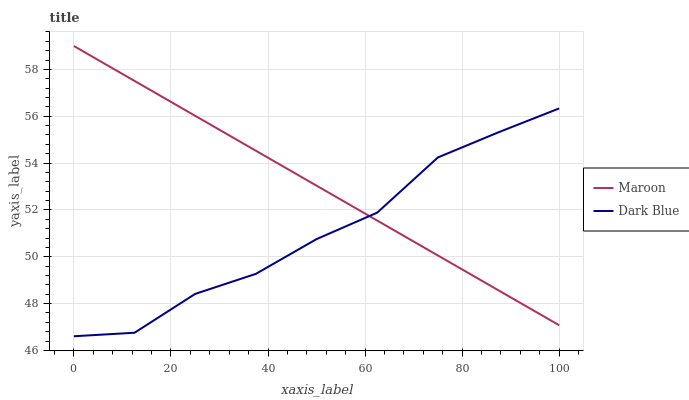Does Dark Blue have the minimum area under the curve?
Answer yes or no. Yes. Does Maroon have the maximum area under the curve?
Answer yes or no. Yes. Does Maroon have the minimum area under the curve?
Answer yes or no. No. Is Maroon the smoothest?
Answer yes or no. Yes. Is Dark Blue the roughest?
Answer yes or no. Yes. Is Maroon the roughest?
Answer yes or no. No. Does Dark Blue have the lowest value?
Answer yes or no. Yes. Does Maroon have the lowest value?
Answer yes or no. No. Does Maroon have the highest value?
Answer yes or no. Yes. Does Maroon intersect Dark Blue?
Answer yes or no. Yes. Is Maroon less than Dark Blue?
Answer yes or no. No. Is Maroon greater than Dark Blue?
Answer yes or no. No. 